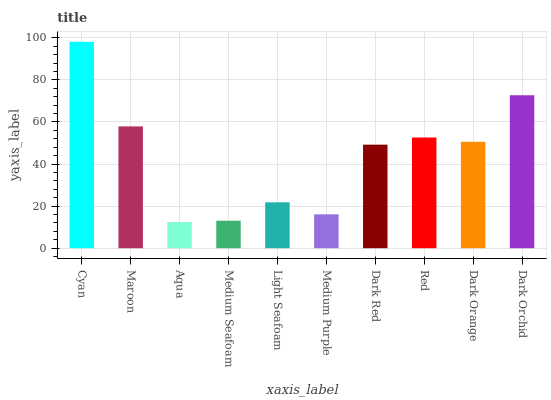Is Maroon the minimum?
Answer yes or no. No. Is Maroon the maximum?
Answer yes or no. No. Is Cyan greater than Maroon?
Answer yes or no. Yes. Is Maroon less than Cyan?
Answer yes or no. Yes. Is Maroon greater than Cyan?
Answer yes or no. No. Is Cyan less than Maroon?
Answer yes or no. No. Is Dark Orange the high median?
Answer yes or no. Yes. Is Dark Red the low median?
Answer yes or no. Yes. Is Aqua the high median?
Answer yes or no. No. Is Maroon the low median?
Answer yes or no. No. 